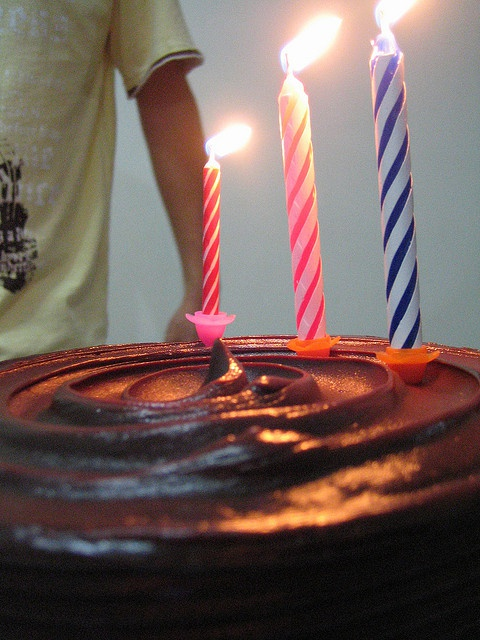Describe the objects in this image and their specific colors. I can see cake in gray, black, maroon, and brown tones and people in gray, olive, and maroon tones in this image. 